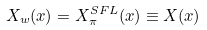<formula> <loc_0><loc_0><loc_500><loc_500>X _ { w } ( x ) = X _ { \pi } ^ { S F L } ( x ) \equiv X ( x )</formula> 